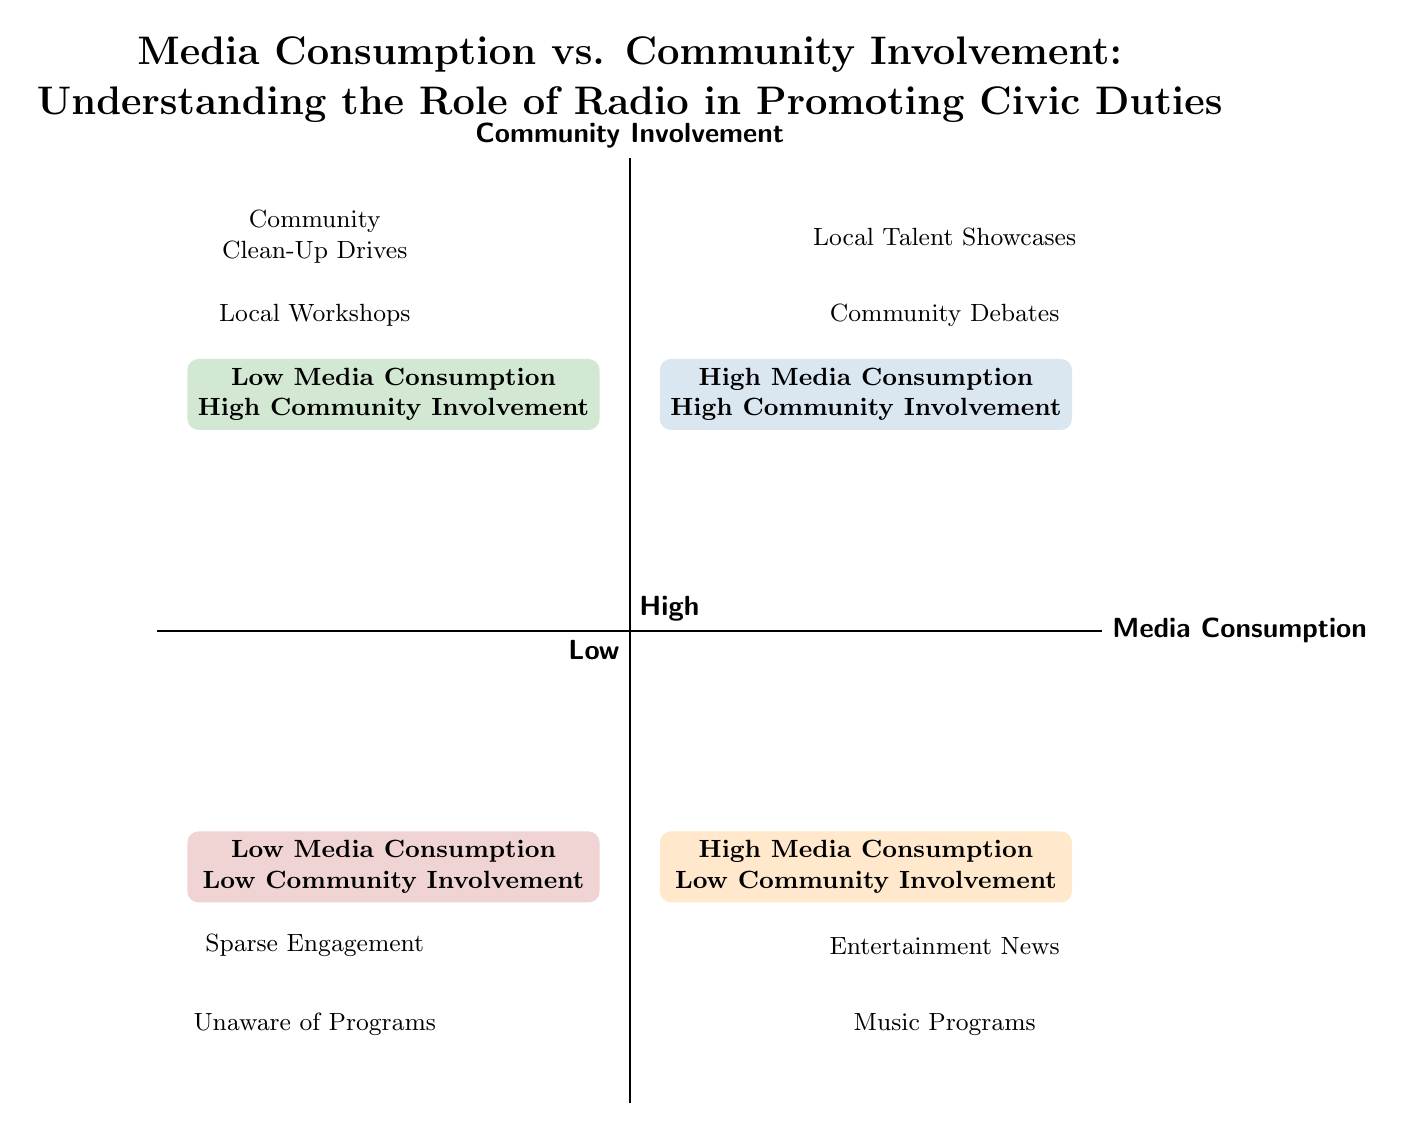What are the two categories in the high media consumption high community involvement quadrant? The high media consumption high community involvement quadrant contains two entries: Local Talent Showcases and Community Debates. Both programs encourage civic participation and community engagement.
Answer: Local Talent Showcases, Community Debates How many entries are there in the low media consumption low community involvement quadrant? In the low media consumption low community involvement quadrant, there are two entries: Sparse Engagement and Unaware of Programs. Therefore, the count is two.
Answer: 2 Which quadrant has programs with significant community participation but low media consumption? The low media consumption high community involvement quadrant includes programs such as Community Clean-Up Drives and Local Workshops, indicating community activities that do not heavily rely on radio promotion.
Answer: Low Media Consumption High Community Involvement What is the common theme found in the high media consumption low community involvement quadrant? This quadrant features entertainment-focused content, such as Entertainment News and Music Programs, which primarily prioritize popular culture rather than community participatory engagement.
Answer: Entertainment-focused content List all programs in the high media consumption low community involvement quadrant. The high media consumption low community involvement quadrant features two programs: Entertainment News and Music Programs. These programs do not encourage community interaction or involvement.
Answer: Entertainment News, Music Programs How are Community Debates categorized in this diagram? Community Debates are categorized in the high media consumption high community involvement quadrant, indicating a strong engagement with social issues and community participation.
Answer: High Media Consumption High Community Involvement Which quadrant should be targeted to increase civic engagement? The high media consumption high community involvement quadrant is where programs can effectively promote civic duties and increase community engagement through radio content, so this quadrant should be targeted.
Answer: High Media Consumption High Community Involvement 